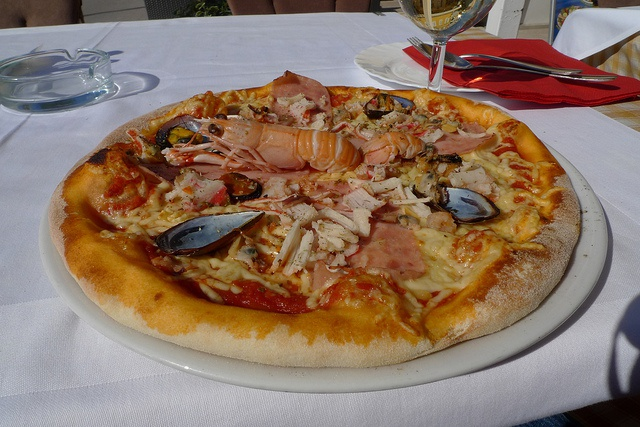Describe the objects in this image and their specific colors. I can see pizza in black, olive, maroon, gray, and tan tones, dining table in black, darkgray, gray, and lightgray tones, bowl in black, gray, and darkgray tones, wine glass in black, gray, maroon, and darkgray tones, and spoon in black, gray, and maroon tones in this image. 